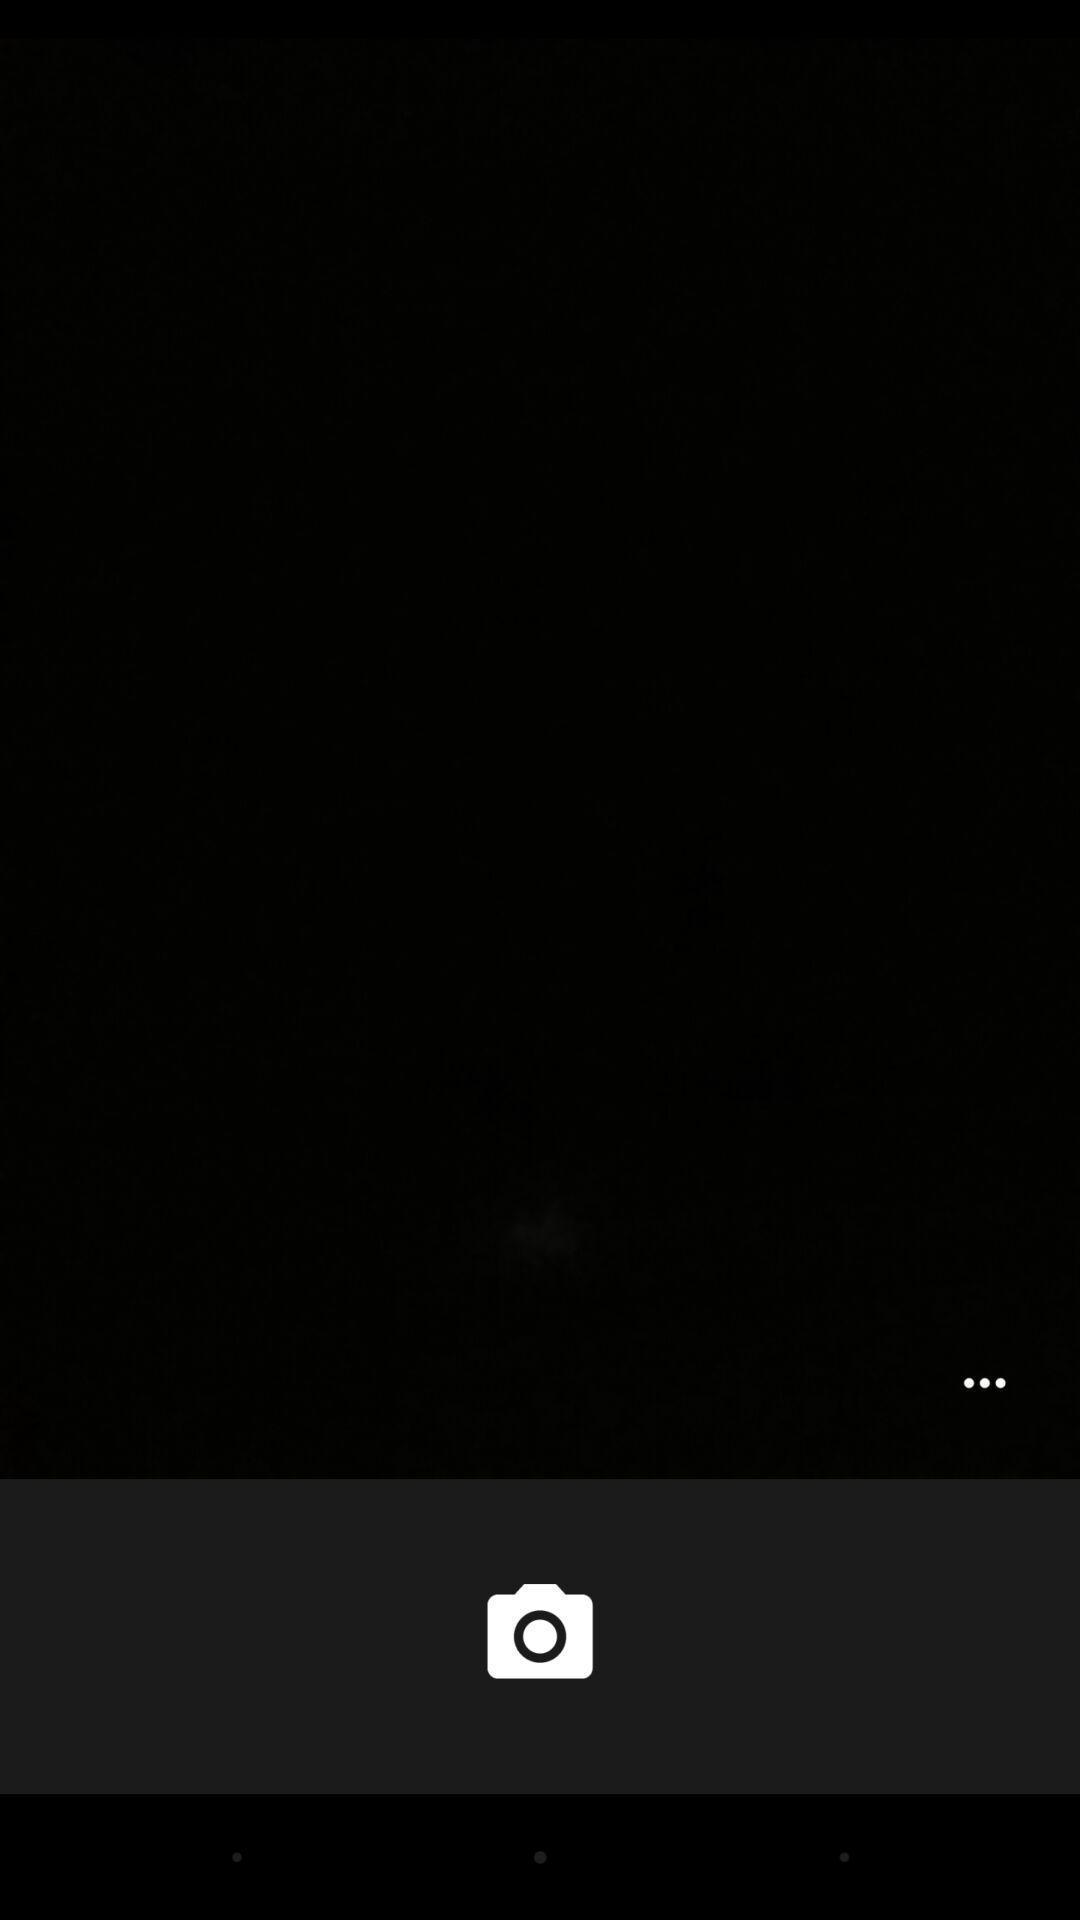Describe the visual elements of this screenshot. Screen shows blank page with camera icon. 